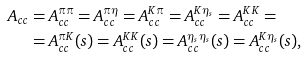Convert formula to latex. <formula><loc_0><loc_0><loc_500><loc_500>A _ { c c } & = A _ { c c } ^ { \pi \pi } = A _ { c c } ^ { \pi \eta } = A _ { c c } ^ { K \pi } = A _ { c c } ^ { K \eta _ { s } } = A _ { c c } ^ { K K } = \\ & = A _ { c c } ^ { \pi K } ( s ) = A _ { c c } ^ { K K } ( s ) = A _ { c c } ^ { \eta _ { s } \eta _ { s } } ( s ) = A _ { c c } ^ { K \eta _ { s } } ( s ) ,</formula> 